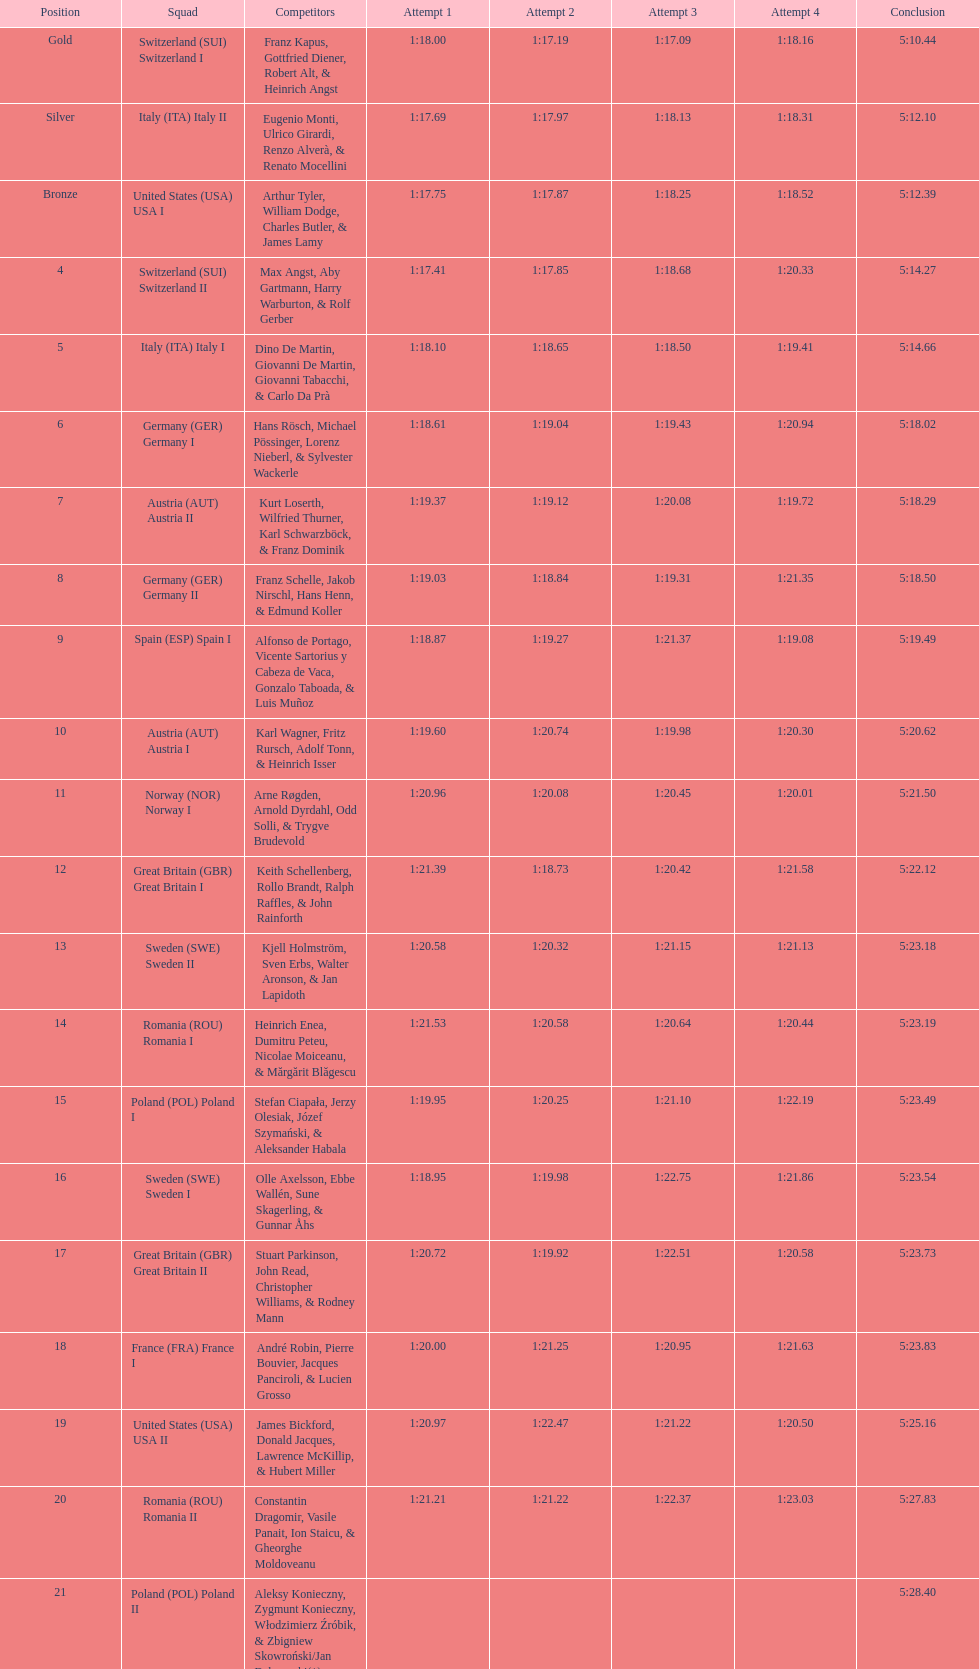What is the total amount of runs? 4. 